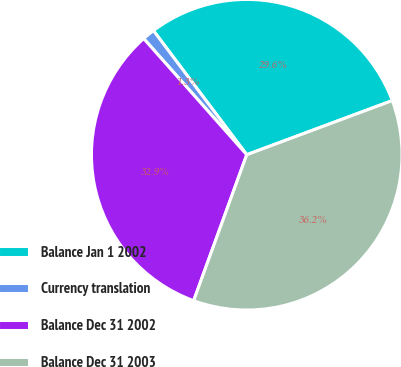Convert chart. <chart><loc_0><loc_0><loc_500><loc_500><pie_chart><fcel>Balance Jan 1 2002<fcel>Currency translation<fcel>Balance Dec 31 2002<fcel>Balance Dec 31 2003<nl><fcel>29.59%<fcel>1.29%<fcel>32.9%<fcel>36.22%<nl></chart> 